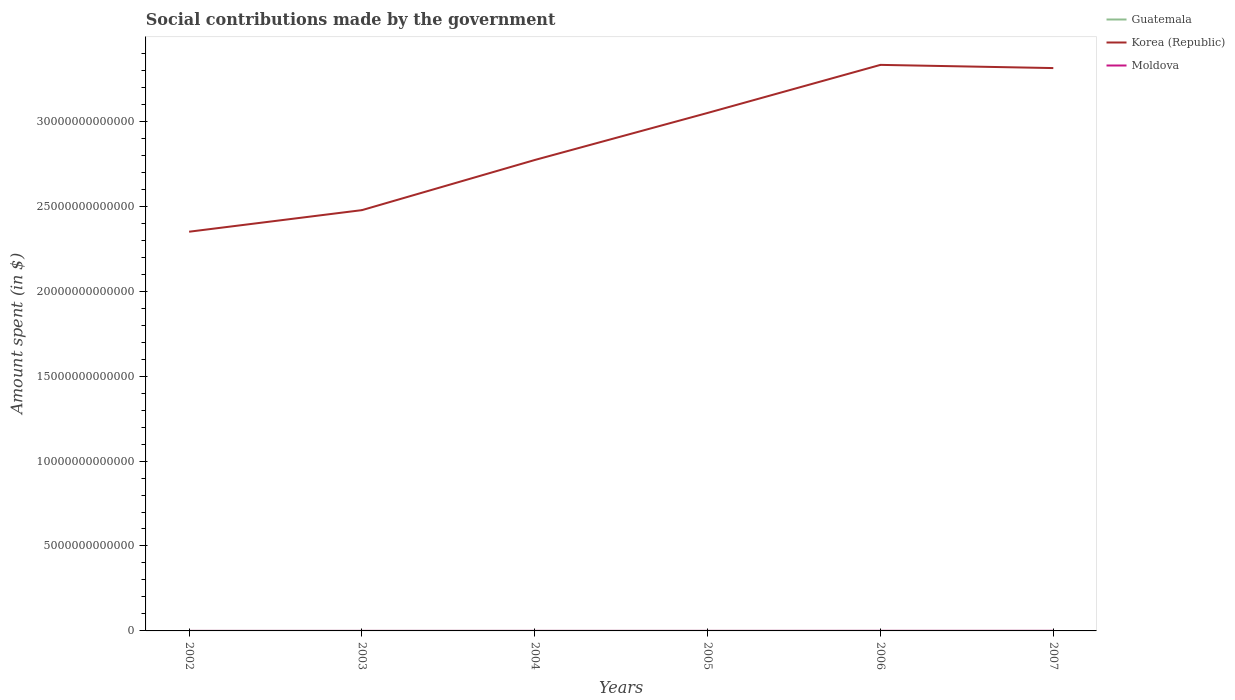Does the line corresponding to Korea (Republic) intersect with the line corresponding to Guatemala?
Offer a very short reply. No. Across all years, what is the maximum amount spent on social contributions in Moldova?
Your answer should be compact. 1.64e+09. What is the total amount spent on social contributions in Moldova in the graph?
Provide a short and direct response. -2.60e+09. What is the difference between the highest and the second highest amount spent on social contributions in Guatemala?
Provide a succinct answer. 1.90e+08. What is the difference between the highest and the lowest amount spent on social contributions in Moldova?
Keep it short and to the point. 2. Is the amount spent on social contributions in Guatemala strictly greater than the amount spent on social contributions in Korea (Republic) over the years?
Give a very brief answer. Yes. What is the difference between two consecutive major ticks on the Y-axis?
Make the answer very short. 5.00e+12. Are the values on the major ticks of Y-axis written in scientific E-notation?
Make the answer very short. No. Does the graph contain grids?
Ensure brevity in your answer.  No. Where does the legend appear in the graph?
Offer a terse response. Top right. How many legend labels are there?
Provide a succinct answer. 3. How are the legend labels stacked?
Your answer should be compact. Vertical. What is the title of the graph?
Offer a very short reply. Social contributions made by the government. Does "Luxembourg" appear as one of the legend labels in the graph?
Offer a very short reply. No. What is the label or title of the Y-axis?
Provide a succinct answer. Amount spent (in $). What is the Amount spent (in $) of Guatemala in 2002?
Ensure brevity in your answer.  4.69e+08. What is the Amount spent (in $) of Korea (Republic) in 2002?
Offer a very short reply. 2.35e+13. What is the Amount spent (in $) in Moldova in 2002?
Provide a succinct answer. 1.64e+09. What is the Amount spent (in $) in Guatemala in 2003?
Your answer should be very brief. 5.05e+08. What is the Amount spent (in $) in Korea (Republic) in 2003?
Ensure brevity in your answer.  2.48e+13. What is the Amount spent (in $) of Moldova in 2003?
Make the answer very short. 1.98e+09. What is the Amount spent (in $) of Guatemala in 2004?
Ensure brevity in your answer.  5.40e+08. What is the Amount spent (in $) of Korea (Republic) in 2004?
Offer a terse response. 2.77e+13. What is the Amount spent (in $) of Moldova in 2004?
Offer a terse response. 2.49e+09. What is the Amount spent (in $) in Guatemala in 2005?
Offer a terse response. 5.50e+08. What is the Amount spent (in $) in Korea (Republic) in 2005?
Offer a very short reply. 3.05e+13. What is the Amount spent (in $) of Moldova in 2005?
Your response must be concise. 2.95e+09. What is the Amount spent (in $) in Guatemala in 2006?
Make the answer very short. 5.85e+08. What is the Amount spent (in $) in Korea (Republic) in 2006?
Make the answer very short. 3.33e+13. What is the Amount spent (in $) in Moldova in 2006?
Your answer should be very brief. 4.24e+09. What is the Amount spent (in $) in Guatemala in 2007?
Your answer should be compact. 6.59e+08. What is the Amount spent (in $) in Korea (Republic) in 2007?
Offer a very short reply. 3.31e+13. What is the Amount spent (in $) of Moldova in 2007?
Your answer should be very brief. 5.12e+09. Across all years, what is the maximum Amount spent (in $) of Guatemala?
Ensure brevity in your answer.  6.59e+08. Across all years, what is the maximum Amount spent (in $) of Korea (Republic)?
Keep it short and to the point. 3.33e+13. Across all years, what is the maximum Amount spent (in $) in Moldova?
Offer a very short reply. 5.12e+09. Across all years, what is the minimum Amount spent (in $) of Guatemala?
Your response must be concise. 4.69e+08. Across all years, what is the minimum Amount spent (in $) in Korea (Republic)?
Your answer should be compact. 2.35e+13. Across all years, what is the minimum Amount spent (in $) in Moldova?
Provide a short and direct response. 1.64e+09. What is the total Amount spent (in $) in Guatemala in the graph?
Offer a terse response. 3.31e+09. What is the total Amount spent (in $) of Korea (Republic) in the graph?
Offer a very short reply. 1.73e+14. What is the total Amount spent (in $) in Moldova in the graph?
Provide a short and direct response. 1.84e+1. What is the difference between the Amount spent (in $) in Guatemala in 2002 and that in 2003?
Your answer should be compact. -3.60e+07. What is the difference between the Amount spent (in $) of Korea (Republic) in 2002 and that in 2003?
Your response must be concise. -1.27e+12. What is the difference between the Amount spent (in $) in Moldova in 2002 and that in 2003?
Your response must be concise. -3.34e+08. What is the difference between the Amount spent (in $) of Guatemala in 2002 and that in 2004?
Offer a terse response. -7.11e+07. What is the difference between the Amount spent (in $) of Korea (Republic) in 2002 and that in 2004?
Make the answer very short. -4.22e+12. What is the difference between the Amount spent (in $) in Moldova in 2002 and that in 2004?
Offer a very short reply. -8.49e+08. What is the difference between the Amount spent (in $) of Guatemala in 2002 and that in 2005?
Offer a very short reply. -8.12e+07. What is the difference between the Amount spent (in $) in Korea (Republic) in 2002 and that in 2005?
Make the answer very short. -6.99e+12. What is the difference between the Amount spent (in $) in Moldova in 2002 and that in 2005?
Give a very brief answer. -1.31e+09. What is the difference between the Amount spent (in $) of Guatemala in 2002 and that in 2006?
Offer a terse response. -1.16e+08. What is the difference between the Amount spent (in $) in Korea (Republic) in 2002 and that in 2006?
Ensure brevity in your answer.  -9.82e+12. What is the difference between the Amount spent (in $) in Moldova in 2002 and that in 2006?
Offer a terse response. -2.60e+09. What is the difference between the Amount spent (in $) of Guatemala in 2002 and that in 2007?
Your answer should be compact. -1.90e+08. What is the difference between the Amount spent (in $) in Korea (Republic) in 2002 and that in 2007?
Your response must be concise. -9.63e+12. What is the difference between the Amount spent (in $) of Moldova in 2002 and that in 2007?
Give a very brief answer. -3.47e+09. What is the difference between the Amount spent (in $) of Guatemala in 2003 and that in 2004?
Your answer should be compact. -3.50e+07. What is the difference between the Amount spent (in $) of Korea (Republic) in 2003 and that in 2004?
Provide a short and direct response. -2.95e+12. What is the difference between the Amount spent (in $) of Moldova in 2003 and that in 2004?
Your answer should be compact. -5.14e+08. What is the difference between the Amount spent (in $) of Guatemala in 2003 and that in 2005?
Your answer should be very brief. -4.52e+07. What is the difference between the Amount spent (in $) in Korea (Republic) in 2003 and that in 2005?
Give a very brief answer. -5.72e+12. What is the difference between the Amount spent (in $) of Moldova in 2003 and that in 2005?
Your response must be concise. -9.71e+08. What is the difference between the Amount spent (in $) in Guatemala in 2003 and that in 2006?
Offer a terse response. -8.04e+07. What is the difference between the Amount spent (in $) in Korea (Republic) in 2003 and that in 2006?
Keep it short and to the point. -8.55e+12. What is the difference between the Amount spent (in $) of Moldova in 2003 and that in 2006?
Offer a terse response. -2.27e+09. What is the difference between the Amount spent (in $) of Guatemala in 2003 and that in 2007?
Make the answer very short. -1.54e+08. What is the difference between the Amount spent (in $) of Korea (Republic) in 2003 and that in 2007?
Offer a terse response. -8.36e+12. What is the difference between the Amount spent (in $) of Moldova in 2003 and that in 2007?
Provide a succinct answer. -3.14e+09. What is the difference between the Amount spent (in $) in Guatemala in 2004 and that in 2005?
Keep it short and to the point. -1.01e+07. What is the difference between the Amount spent (in $) of Korea (Republic) in 2004 and that in 2005?
Provide a succinct answer. -2.77e+12. What is the difference between the Amount spent (in $) in Moldova in 2004 and that in 2005?
Your answer should be very brief. -4.57e+08. What is the difference between the Amount spent (in $) of Guatemala in 2004 and that in 2006?
Offer a very short reply. -4.54e+07. What is the difference between the Amount spent (in $) of Korea (Republic) in 2004 and that in 2006?
Your answer should be compact. -5.60e+12. What is the difference between the Amount spent (in $) of Moldova in 2004 and that in 2006?
Provide a short and direct response. -1.75e+09. What is the difference between the Amount spent (in $) in Guatemala in 2004 and that in 2007?
Keep it short and to the point. -1.19e+08. What is the difference between the Amount spent (in $) in Korea (Republic) in 2004 and that in 2007?
Provide a succinct answer. -5.41e+12. What is the difference between the Amount spent (in $) of Moldova in 2004 and that in 2007?
Ensure brevity in your answer.  -2.62e+09. What is the difference between the Amount spent (in $) of Guatemala in 2005 and that in 2006?
Your response must be concise. -3.53e+07. What is the difference between the Amount spent (in $) in Korea (Republic) in 2005 and that in 2006?
Your answer should be compact. -2.83e+12. What is the difference between the Amount spent (in $) in Moldova in 2005 and that in 2006?
Your response must be concise. -1.29e+09. What is the difference between the Amount spent (in $) in Guatemala in 2005 and that in 2007?
Your answer should be compact. -1.09e+08. What is the difference between the Amount spent (in $) in Korea (Republic) in 2005 and that in 2007?
Offer a very short reply. -2.64e+12. What is the difference between the Amount spent (in $) in Moldova in 2005 and that in 2007?
Give a very brief answer. -2.17e+09. What is the difference between the Amount spent (in $) of Guatemala in 2006 and that in 2007?
Keep it short and to the point. -7.35e+07. What is the difference between the Amount spent (in $) of Korea (Republic) in 2006 and that in 2007?
Your answer should be compact. 1.88e+11. What is the difference between the Amount spent (in $) in Moldova in 2006 and that in 2007?
Offer a very short reply. -8.72e+08. What is the difference between the Amount spent (in $) in Guatemala in 2002 and the Amount spent (in $) in Korea (Republic) in 2003?
Provide a succinct answer. -2.48e+13. What is the difference between the Amount spent (in $) of Guatemala in 2002 and the Amount spent (in $) of Moldova in 2003?
Provide a succinct answer. -1.51e+09. What is the difference between the Amount spent (in $) in Korea (Republic) in 2002 and the Amount spent (in $) in Moldova in 2003?
Keep it short and to the point. 2.35e+13. What is the difference between the Amount spent (in $) of Guatemala in 2002 and the Amount spent (in $) of Korea (Republic) in 2004?
Your answer should be compact. -2.77e+13. What is the difference between the Amount spent (in $) of Guatemala in 2002 and the Amount spent (in $) of Moldova in 2004?
Offer a terse response. -2.02e+09. What is the difference between the Amount spent (in $) in Korea (Republic) in 2002 and the Amount spent (in $) in Moldova in 2004?
Provide a short and direct response. 2.35e+13. What is the difference between the Amount spent (in $) in Guatemala in 2002 and the Amount spent (in $) in Korea (Republic) in 2005?
Make the answer very short. -3.05e+13. What is the difference between the Amount spent (in $) in Guatemala in 2002 and the Amount spent (in $) in Moldova in 2005?
Offer a very short reply. -2.48e+09. What is the difference between the Amount spent (in $) in Korea (Republic) in 2002 and the Amount spent (in $) in Moldova in 2005?
Ensure brevity in your answer.  2.35e+13. What is the difference between the Amount spent (in $) in Guatemala in 2002 and the Amount spent (in $) in Korea (Republic) in 2006?
Make the answer very short. -3.33e+13. What is the difference between the Amount spent (in $) in Guatemala in 2002 and the Amount spent (in $) in Moldova in 2006?
Your answer should be very brief. -3.78e+09. What is the difference between the Amount spent (in $) of Korea (Republic) in 2002 and the Amount spent (in $) of Moldova in 2006?
Offer a terse response. 2.35e+13. What is the difference between the Amount spent (in $) of Guatemala in 2002 and the Amount spent (in $) of Korea (Republic) in 2007?
Your answer should be very brief. -3.31e+13. What is the difference between the Amount spent (in $) in Guatemala in 2002 and the Amount spent (in $) in Moldova in 2007?
Your answer should be compact. -4.65e+09. What is the difference between the Amount spent (in $) in Korea (Republic) in 2002 and the Amount spent (in $) in Moldova in 2007?
Ensure brevity in your answer.  2.35e+13. What is the difference between the Amount spent (in $) of Guatemala in 2003 and the Amount spent (in $) of Korea (Republic) in 2004?
Your answer should be compact. -2.77e+13. What is the difference between the Amount spent (in $) of Guatemala in 2003 and the Amount spent (in $) of Moldova in 2004?
Your response must be concise. -1.99e+09. What is the difference between the Amount spent (in $) of Korea (Republic) in 2003 and the Amount spent (in $) of Moldova in 2004?
Your answer should be very brief. 2.48e+13. What is the difference between the Amount spent (in $) in Guatemala in 2003 and the Amount spent (in $) in Korea (Republic) in 2005?
Your answer should be very brief. -3.05e+13. What is the difference between the Amount spent (in $) of Guatemala in 2003 and the Amount spent (in $) of Moldova in 2005?
Ensure brevity in your answer.  -2.44e+09. What is the difference between the Amount spent (in $) of Korea (Republic) in 2003 and the Amount spent (in $) of Moldova in 2005?
Your answer should be compact. 2.48e+13. What is the difference between the Amount spent (in $) in Guatemala in 2003 and the Amount spent (in $) in Korea (Republic) in 2006?
Give a very brief answer. -3.33e+13. What is the difference between the Amount spent (in $) of Guatemala in 2003 and the Amount spent (in $) of Moldova in 2006?
Offer a very short reply. -3.74e+09. What is the difference between the Amount spent (in $) of Korea (Republic) in 2003 and the Amount spent (in $) of Moldova in 2006?
Offer a terse response. 2.48e+13. What is the difference between the Amount spent (in $) in Guatemala in 2003 and the Amount spent (in $) in Korea (Republic) in 2007?
Ensure brevity in your answer.  -3.31e+13. What is the difference between the Amount spent (in $) of Guatemala in 2003 and the Amount spent (in $) of Moldova in 2007?
Ensure brevity in your answer.  -4.61e+09. What is the difference between the Amount spent (in $) of Korea (Republic) in 2003 and the Amount spent (in $) of Moldova in 2007?
Give a very brief answer. 2.48e+13. What is the difference between the Amount spent (in $) of Guatemala in 2004 and the Amount spent (in $) of Korea (Republic) in 2005?
Make the answer very short. -3.05e+13. What is the difference between the Amount spent (in $) of Guatemala in 2004 and the Amount spent (in $) of Moldova in 2005?
Provide a short and direct response. -2.41e+09. What is the difference between the Amount spent (in $) of Korea (Republic) in 2004 and the Amount spent (in $) of Moldova in 2005?
Keep it short and to the point. 2.77e+13. What is the difference between the Amount spent (in $) of Guatemala in 2004 and the Amount spent (in $) of Korea (Republic) in 2006?
Give a very brief answer. -3.33e+13. What is the difference between the Amount spent (in $) of Guatemala in 2004 and the Amount spent (in $) of Moldova in 2006?
Keep it short and to the point. -3.70e+09. What is the difference between the Amount spent (in $) of Korea (Republic) in 2004 and the Amount spent (in $) of Moldova in 2006?
Keep it short and to the point. 2.77e+13. What is the difference between the Amount spent (in $) of Guatemala in 2004 and the Amount spent (in $) of Korea (Republic) in 2007?
Give a very brief answer. -3.31e+13. What is the difference between the Amount spent (in $) of Guatemala in 2004 and the Amount spent (in $) of Moldova in 2007?
Offer a terse response. -4.58e+09. What is the difference between the Amount spent (in $) in Korea (Republic) in 2004 and the Amount spent (in $) in Moldova in 2007?
Give a very brief answer. 2.77e+13. What is the difference between the Amount spent (in $) in Guatemala in 2005 and the Amount spent (in $) in Korea (Republic) in 2006?
Offer a very short reply. -3.33e+13. What is the difference between the Amount spent (in $) in Guatemala in 2005 and the Amount spent (in $) in Moldova in 2006?
Your response must be concise. -3.69e+09. What is the difference between the Amount spent (in $) in Korea (Republic) in 2005 and the Amount spent (in $) in Moldova in 2006?
Offer a very short reply. 3.05e+13. What is the difference between the Amount spent (in $) of Guatemala in 2005 and the Amount spent (in $) of Korea (Republic) in 2007?
Offer a very short reply. -3.31e+13. What is the difference between the Amount spent (in $) in Guatemala in 2005 and the Amount spent (in $) in Moldova in 2007?
Your answer should be very brief. -4.57e+09. What is the difference between the Amount spent (in $) in Korea (Republic) in 2005 and the Amount spent (in $) in Moldova in 2007?
Offer a very short reply. 3.05e+13. What is the difference between the Amount spent (in $) of Guatemala in 2006 and the Amount spent (in $) of Korea (Republic) in 2007?
Your response must be concise. -3.31e+13. What is the difference between the Amount spent (in $) in Guatemala in 2006 and the Amount spent (in $) in Moldova in 2007?
Provide a short and direct response. -4.53e+09. What is the difference between the Amount spent (in $) of Korea (Republic) in 2006 and the Amount spent (in $) of Moldova in 2007?
Provide a short and direct response. 3.33e+13. What is the average Amount spent (in $) in Guatemala per year?
Ensure brevity in your answer.  5.51e+08. What is the average Amount spent (in $) of Korea (Republic) per year?
Your response must be concise. 2.88e+13. What is the average Amount spent (in $) of Moldova per year?
Your answer should be compact. 3.07e+09. In the year 2002, what is the difference between the Amount spent (in $) of Guatemala and Amount spent (in $) of Korea (Republic)?
Offer a terse response. -2.35e+13. In the year 2002, what is the difference between the Amount spent (in $) of Guatemala and Amount spent (in $) of Moldova?
Offer a terse response. -1.18e+09. In the year 2002, what is the difference between the Amount spent (in $) in Korea (Republic) and Amount spent (in $) in Moldova?
Your answer should be very brief. 2.35e+13. In the year 2003, what is the difference between the Amount spent (in $) in Guatemala and Amount spent (in $) in Korea (Republic)?
Keep it short and to the point. -2.48e+13. In the year 2003, what is the difference between the Amount spent (in $) of Guatemala and Amount spent (in $) of Moldova?
Give a very brief answer. -1.47e+09. In the year 2003, what is the difference between the Amount spent (in $) in Korea (Republic) and Amount spent (in $) in Moldova?
Your answer should be very brief. 2.48e+13. In the year 2004, what is the difference between the Amount spent (in $) of Guatemala and Amount spent (in $) of Korea (Republic)?
Provide a succinct answer. -2.77e+13. In the year 2004, what is the difference between the Amount spent (in $) of Guatemala and Amount spent (in $) of Moldova?
Your response must be concise. -1.95e+09. In the year 2004, what is the difference between the Amount spent (in $) in Korea (Republic) and Amount spent (in $) in Moldova?
Give a very brief answer. 2.77e+13. In the year 2005, what is the difference between the Amount spent (in $) in Guatemala and Amount spent (in $) in Korea (Republic)?
Provide a short and direct response. -3.05e+13. In the year 2005, what is the difference between the Amount spent (in $) of Guatemala and Amount spent (in $) of Moldova?
Your response must be concise. -2.40e+09. In the year 2005, what is the difference between the Amount spent (in $) in Korea (Republic) and Amount spent (in $) in Moldova?
Your answer should be very brief. 3.05e+13. In the year 2006, what is the difference between the Amount spent (in $) in Guatemala and Amount spent (in $) in Korea (Republic)?
Your answer should be very brief. -3.33e+13. In the year 2006, what is the difference between the Amount spent (in $) in Guatemala and Amount spent (in $) in Moldova?
Keep it short and to the point. -3.66e+09. In the year 2006, what is the difference between the Amount spent (in $) of Korea (Republic) and Amount spent (in $) of Moldova?
Provide a short and direct response. 3.33e+13. In the year 2007, what is the difference between the Amount spent (in $) of Guatemala and Amount spent (in $) of Korea (Republic)?
Make the answer very short. -3.31e+13. In the year 2007, what is the difference between the Amount spent (in $) of Guatemala and Amount spent (in $) of Moldova?
Your answer should be compact. -4.46e+09. In the year 2007, what is the difference between the Amount spent (in $) of Korea (Republic) and Amount spent (in $) of Moldova?
Offer a very short reply. 3.31e+13. What is the ratio of the Amount spent (in $) of Guatemala in 2002 to that in 2003?
Make the answer very short. 0.93. What is the ratio of the Amount spent (in $) in Korea (Republic) in 2002 to that in 2003?
Ensure brevity in your answer.  0.95. What is the ratio of the Amount spent (in $) of Moldova in 2002 to that in 2003?
Your answer should be compact. 0.83. What is the ratio of the Amount spent (in $) in Guatemala in 2002 to that in 2004?
Keep it short and to the point. 0.87. What is the ratio of the Amount spent (in $) of Korea (Republic) in 2002 to that in 2004?
Your response must be concise. 0.85. What is the ratio of the Amount spent (in $) in Moldova in 2002 to that in 2004?
Make the answer very short. 0.66. What is the ratio of the Amount spent (in $) in Guatemala in 2002 to that in 2005?
Offer a very short reply. 0.85. What is the ratio of the Amount spent (in $) of Korea (Republic) in 2002 to that in 2005?
Ensure brevity in your answer.  0.77. What is the ratio of the Amount spent (in $) of Moldova in 2002 to that in 2005?
Your answer should be compact. 0.56. What is the ratio of the Amount spent (in $) of Guatemala in 2002 to that in 2006?
Your answer should be compact. 0.8. What is the ratio of the Amount spent (in $) of Korea (Republic) in 2002 to that in 2006?
Provide a short and direct response. 0.71. What is the ratio of the Amount spent (in $) in Moldova in 2002 to that in 2006?
Offer a terse response. 0.39. What is the ratio of the Amount spent (in $) of Guatemala in 2002 to that in 2007?
Make the answer very short. 0.71. What is the ratio of the Amount spent (in $) of Korea (Republic) in 2002 to that in 2007?
Make the answer very short. 0.71. What is the ratio of the Amount spent (in $) of Moldova in 2002 to that in 2007?
Offer a very short reply. 0.32. What is the ratio of the Amount spent (in $) of Guatemala in 2003 to that in 2004?
Give a very brief answer. 0.94. What is the ratio of the Amount spent (in $) of Korea (Republic) in 2003 to that in 2004?
Keep it short and to the point. 0.89. What is the ratio of the Amount spent (in $) of Moldova in 2003 to that in 2004?
Provide a succinct answer. 0.79. What is the ratio of the Amount spent (in $) of Guatemala in 2003 to that in 2005?
Your answer should be compact. 0.92. What is the ratio of the Amount spent (in $) in Korea (Republic) in 2003 to that in 2005?
Your answer should be very brief. 0.81. What is the ratio of the Amount spent (in $) of Moldova in 2003 to that in 2005?
Offer a terse response. 0.67. What is the ratio of the Amount spent (in $) in Guatemala in 2003 to that in 2006?
Provide a succinct answer. 0.86. What is the ratio of the Amount spent (in $) in Korea (Republic) in 2003 to that in 2006?
Offer a terse response. 0.74. What is the ratio of the Amount spent (in $) of Moldova in 2003 to that in 2006?
Your response must be concise. 0.47. What is the ratio of the Amount spent (in $) in Guatemala in 2003 to that in 2007?
Make the answer very short. 0.77. What is the ratio of the Amount spent (in $) in Korea (Republic) in 2003 to that in 2007?
Make the answer very short. 0.75. What is the ratio of the Amount spent (in $) of Moldova in 2003 to that in 2007?
Your answer should be compact. 0.39. What is the ratio of the Amount spent (in $) of Guatemala in 2004 to that in 2005?
Your answer should be compact. 0.98. What is the ratio of the Amount spent (in $) of Korea (Republic) in 2004 to that in 2005?
Your answer should be very brief. 0.91. What is the ratio of the Amount spent (in $) in Moldova in 2004 to that in 2005?
Your answer should be very brief. 0.85. What is the ratio of the Amount spent (in $) of Guatemala in 2004 to that in 2006?
Provide a short and direct response. 0.92. What is the ratio of the Amount spent (in $) of Korea (Republic) in 2004 to that in 2006?
Ensure brevity in your answer.  0.83. What is the ratio of the Amount spent (in $) in Moldova in 2004 to that in 2006?
Offer a terse response. 0.59. What is the ratio of the Amount spent (in $) of Guatemala in 2004 to that in 2007?
Your answer should be very brief. 0.82. What is the ratio of the Amount spent (in $) of Korea (Republic) in 2004 to that in 2007?
Your answer should be compact. 0.84. What is the ratio of the Amount spent (in $) in Moldova in 2004 to that in 2007?
Provide a short and direct response. 0.49. What is the ratio of the Amount spent (in $) in Guatemala in 2005 to that in 2006?
Make the answer very short. 0.94. What is the ratio of the Amount spent (in $) of Korea (Republic) in 2005 to that in 2006?
Provide a succinct answer. 0.92. What is the ratio of the Amount spent (in $) in Moldova in 2005 to that in 2006?
Keep it short and to the point. 0.69. What is the ratio of the Amount spent (in $) in Guatemala in 2005 to that in 2007?
Provide a short and direct response. 0.83. What is the ratio of the Amount spent (in $) in Korea (Republic) in 2005 to that in 2007?
Make the answer very short. 0.92. What is the ratio of the Amount spent (in $) of Moldova in 2005 to that in 2007?
Provide a succinct answer. 0.58. What is the ratio of the Amount spent (in $) in Guatemala in 2006 to that in 2007?
Your answer should be compact. 0.89. What is the ratio of the Amount spent (in $) in Moldova in 2006 to that in 2007?
Your answer should be very brief. 0.83. What is the difference between the highest and the second highest Amount spent (in $) in Guatemala?
Offer a terse response. 7.35e+07. What is the difference between the highest and the second highest Amount spent (in $) in Korea (Republic)?
Your answer should be compact. 1.88e+11. What is the difference between the highest and the second highest Amount spent (in $) in Moldova?
Offer a terse response. 8.72e+08. What is the difference between the highest and the lowest Amount spent (in $) in Guatemala?
Ensure brevity in your answer.  1.90e+08. What is the difference between the highest and the lowest Amount spent (in $) in Korea (Republic)?
Provide a succinct answer. 9.82e+12. What is the difference between the highest and the lowest Amount spent (in $) of Moldova?
Keep it short and to the point. 3.47e+09. 